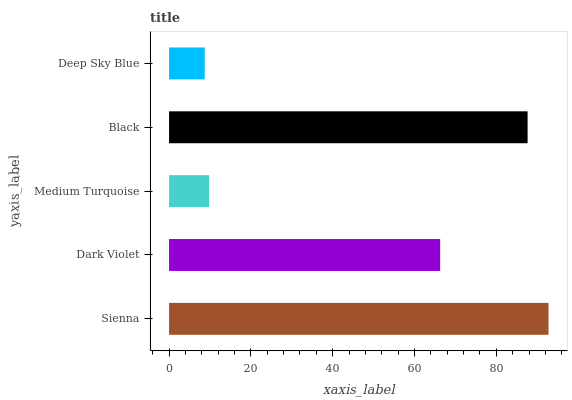Is Deep Sky Blue the minimum?
Answer yes or no. Yes. Is Sienna the maximum?
Answer yes or no. Yes. Is Dark Violet the minimum?
Answer yes or no. No. Is Dark Violet the maximum?
Answer yes or no. No. Is Sienna greater than Dark Violet?
Answer yes or no. Yes. Is Dark Violet less than Sienna?
Answer yes or no. Yes. Is Dark Violet greater than Sienna?
Answer yes or no. No. Is Sienna less than Dark Violet?
Answer yes or no. No. Is Dark Violet the high median?
Answer yes or no. Yes. Is Dark Violet the low median?
Answer yes or no. Yes. Is Black the high median?
Answer yes or no. No. Is Medium Turquoise the low median?
Answer yes or no. No. 